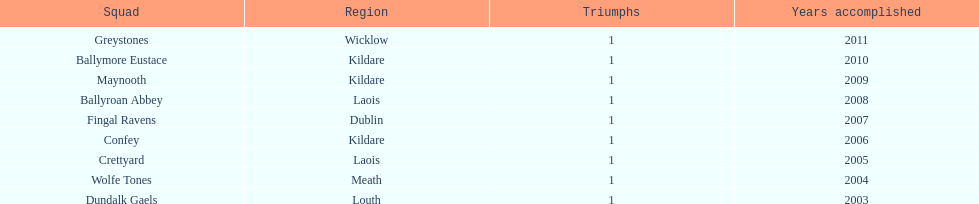Parse the table in full. {'header': ['Squad', 'Region', 'Triumphs', 'Years accomplished'], 'rows': [['Greystones', 'Wicklow', '1', '2011'], ['Ballymore Eustace', 'Kildare', '1', '2010'], ['Maynooth', 'Kildare', '1', '2009'], ['Ballyroan Abbey', 'Laois', '1', '2008'], ['Fingal Ravens', 'Dublin', '1', '2007'], ['Confey', 'Kildare', '1', '2006'], ['Crettyard', 'Laois', '1', '2005'], ['Wolfe Tones', 'Meath', '1', '2004'], ['Dundalk Gaels', 'Louth', '1', '2003']]} Which team was the previous winner before ballyroan abbey in 2008? Fingal Ravens. 